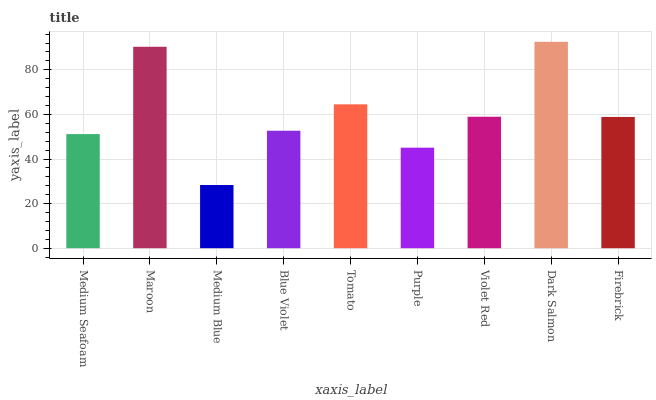Is Medium Blue the minimum?
Answer yes or no. Yes. Is Dark Salmon the maximum?
Answer yes or no. Yes. Is Maroon the minimum?
Answer yes or no. No. Is Maroon the maximum?
Answer yes or no. No. Is Maroon greater than Medium Seafoam?
Answer yes or no. Yes. Is Medium Seafoam less than Maroon?
Answer yes or no. Yes. Is Medium Seafoam greater than Maroon?
Answer yes or no. No. Is Maroon less than Medium Seafoam?
Answer yes or no. No. Is Firebrick the high median?
Answer yes or no. Yes. Is Firebrick the low median?
Answer yes or no. Yes. Is Violet Red the high median?
Answer yes or no. No. Is Medium Seafoam the low median?
Answer yes or no. No. 